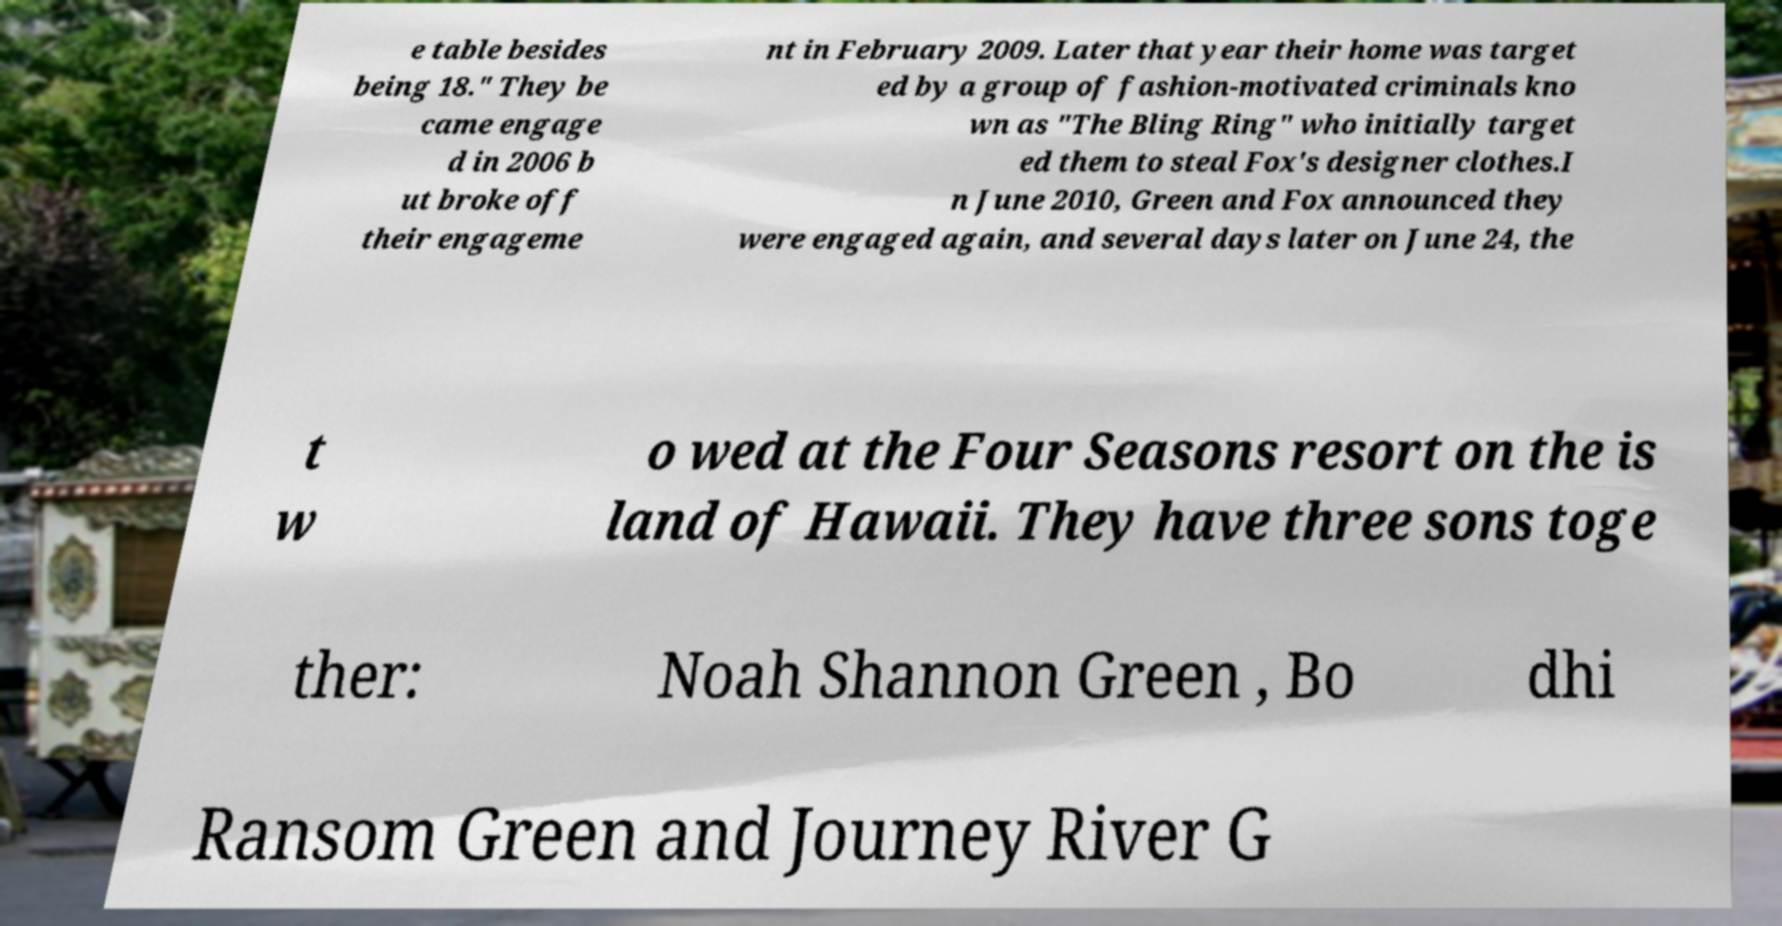Can you read and provide the text displayed in the image?This photo seems to have some interesting text. Can you extract and type it out for me? e table besides being 18." They be came engage d in 2006 b ut broke off their engageme nt in February 2009. Later that year their home was target ed by a group of fashion-motivated criminals kno wn as "The Bling Ring" who initially target ed them to steal Fox's designer clothes.I n June 2010, Green and Fox announced they were engaged again, and several days later on June 24, the t w o wed at the Four Seasons resort on the is land of Hawaii. They have three sons toge ther: Noah Shannon Green , Bo dhi Ransom Green and Journey River G 